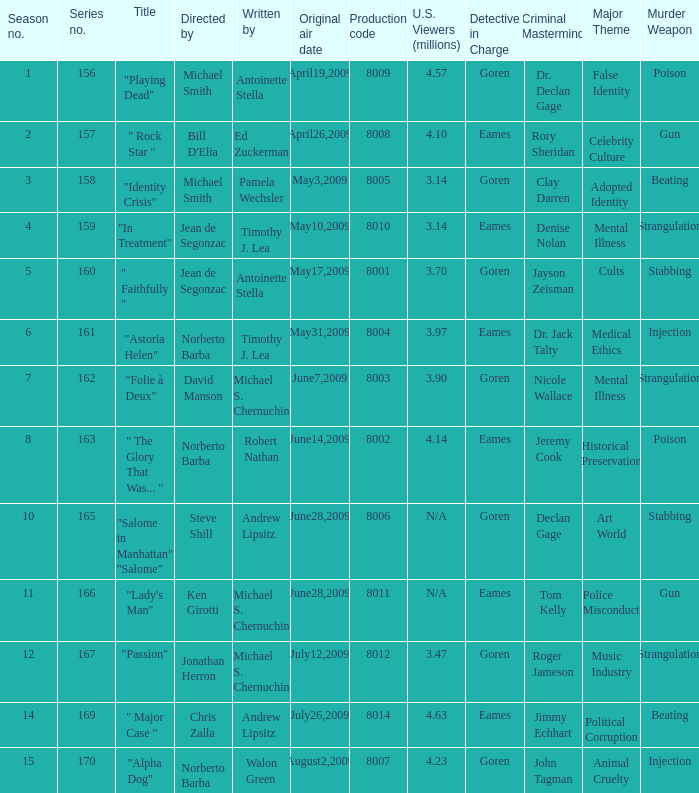Who are the writer of the series episode number 170? Walon Green. 